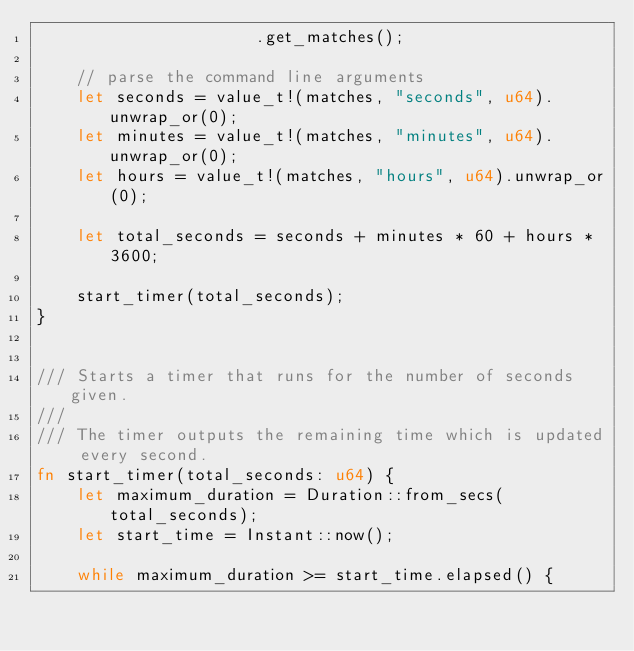Convert code to text. <code><loc_0><loc_0><loc_500><loc_500><_Rust_>                      .get_matches();

    // parse the command line arguments
    let seconds = value_t!(matches, "seconds", u64).unwrap_or(0);
    let minutes = value_t!(matches, "minutes", u64).unwrap_or(0);
    let hours = value_t!(matches, "hours", u64).unwrap_or(0);

    let total_seconds = seconds + minutes * 60 + hours * 3600;

    start_timer(total_seconds);
}


/// Starts a timer that runs for the number of seconds given.
///
/// The timer outputs the remaining time which is updated every second.
fn start_timer(total_seconds: u64) {
    let maximum_duration = Duration::from_secs(total_seconds);
    let start_time = Instant::now();

    while maximum_duration >= start_time.elapsed() {</code> 